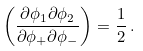<formula> <loc_0><loc_0><loc_500><loc_500>\left ( \frac { \partial \phi _ { 1 } \partial \phi _ { 2 } } { \partial \phi _ { + } \partial \phi _ { - } } \right ) = \frac { 1 } { 2 } \, .</formula> 